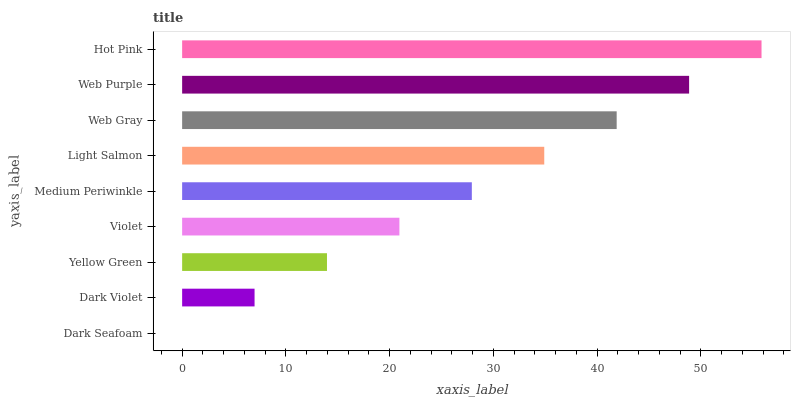Is Dark Seafoam the minimum?
Answer yes or no. Yes. Is Hot Pink the maximum?
Answer yes or no. Yes. Is Dark Violet the minimum?
Answer yes or no. No. Is Dark Violet the maximum?
Answer yes or no. No. Is Dark Violet greater than Dark Seafoam?
Answer yes or no. Yes. Is Dark Seafoam less than Dark Violet?
Answer yes or no. Yes. Is Dark Seafoam greater than Dark Violet?
Answer yes or no. No. Is Dark Violet less than Dark Seafoam?
Answer yes or no. No. Is Medium Periwinkle the high median?
Answer yes or no. Yes. Is Medium Periwinkle the low median?
Answer yes or no. Yes. Is Light Salmon the high median?
Answer yes or no. No. Is Web Gray the low median?
Answer yes or no. No. 